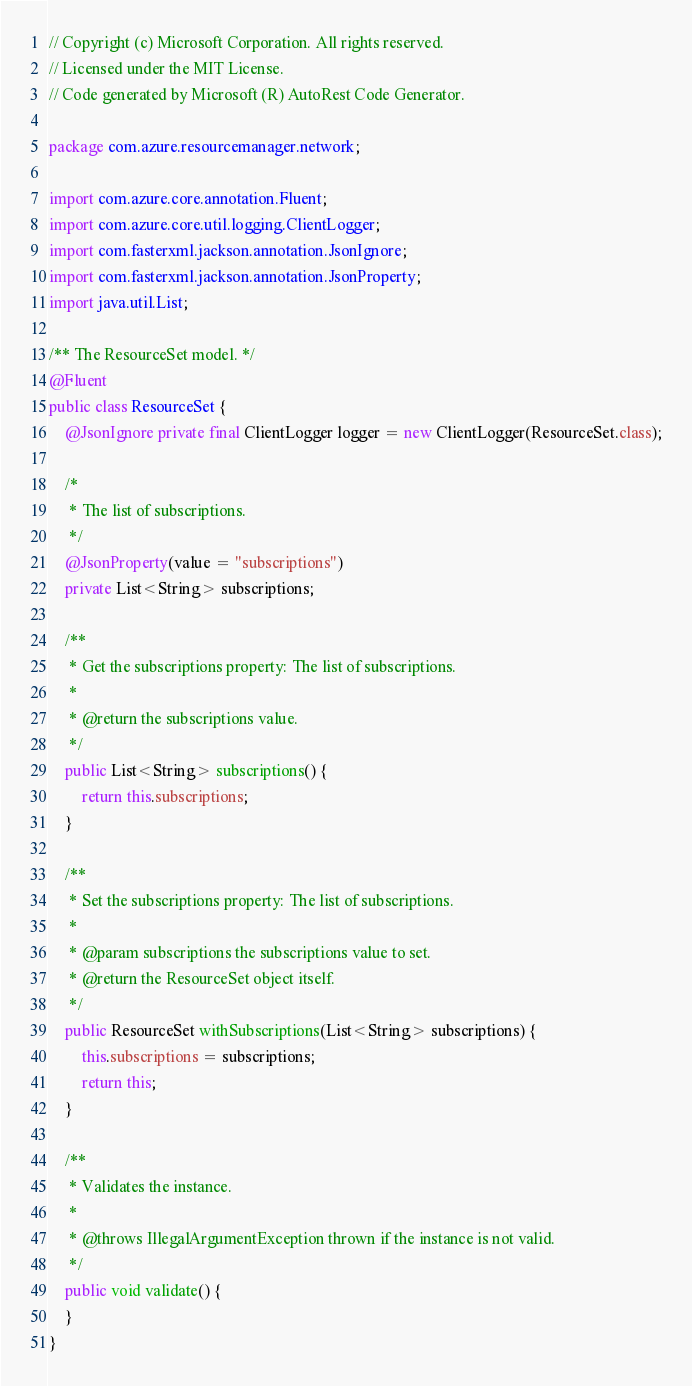Convert code to text. <code><loc_0><loc_0><loc_500><loc_500><_Java_>// Copyright (c) Microsoft Corporation. All rights reserved.
// Licensed under the MIT License.
// Code generated by Microsoft (R) AutoRest Code Generator.

package com.azure.resourcemanager.network;

import com.azure.core.annotation.Fluent;
import com.azure.core.util.logging.ClientLogger;
import com.fasterxml.jackson.annotation.JsonIgnore;
import com.fasterxml.jackson.annotation.JsonProperty;
import java.util.List;

/** The ResourceSet model. */
@Fluent
public class ResourceSet {
    @JsonIgnore private final ClientLogger logger = new ClientLogger(ResourceSet.class);

    /*
     * The list of subscriptions.
     */
    @JsonProperty(value = "subscriptions")
    private List<String> subscriptions;

    /**
     * Get the subscriptions property: The list of subscriptions.
     *
     * @return the subscriptions value.
     */
    public List<String> subscriptions() {
        return this.subscriptions;
    }

    /**
     * Set the subscriptions property: The list of subscriptions.
     *
     * @param subscriptions the subscriptions value to set.
     * @return the ResourceSet object itself.
     */
    public ResourceSet withSubscriptions(List<String> subscriptions) {
        this.subscriptions = subscriptions;
        return this;
    }

    /**
     * Validates the instance.
     *
     * @throws IllegalArgumentException thrown if the instance is not valid.
     */
    public void validate() {
    }
}
</code> 